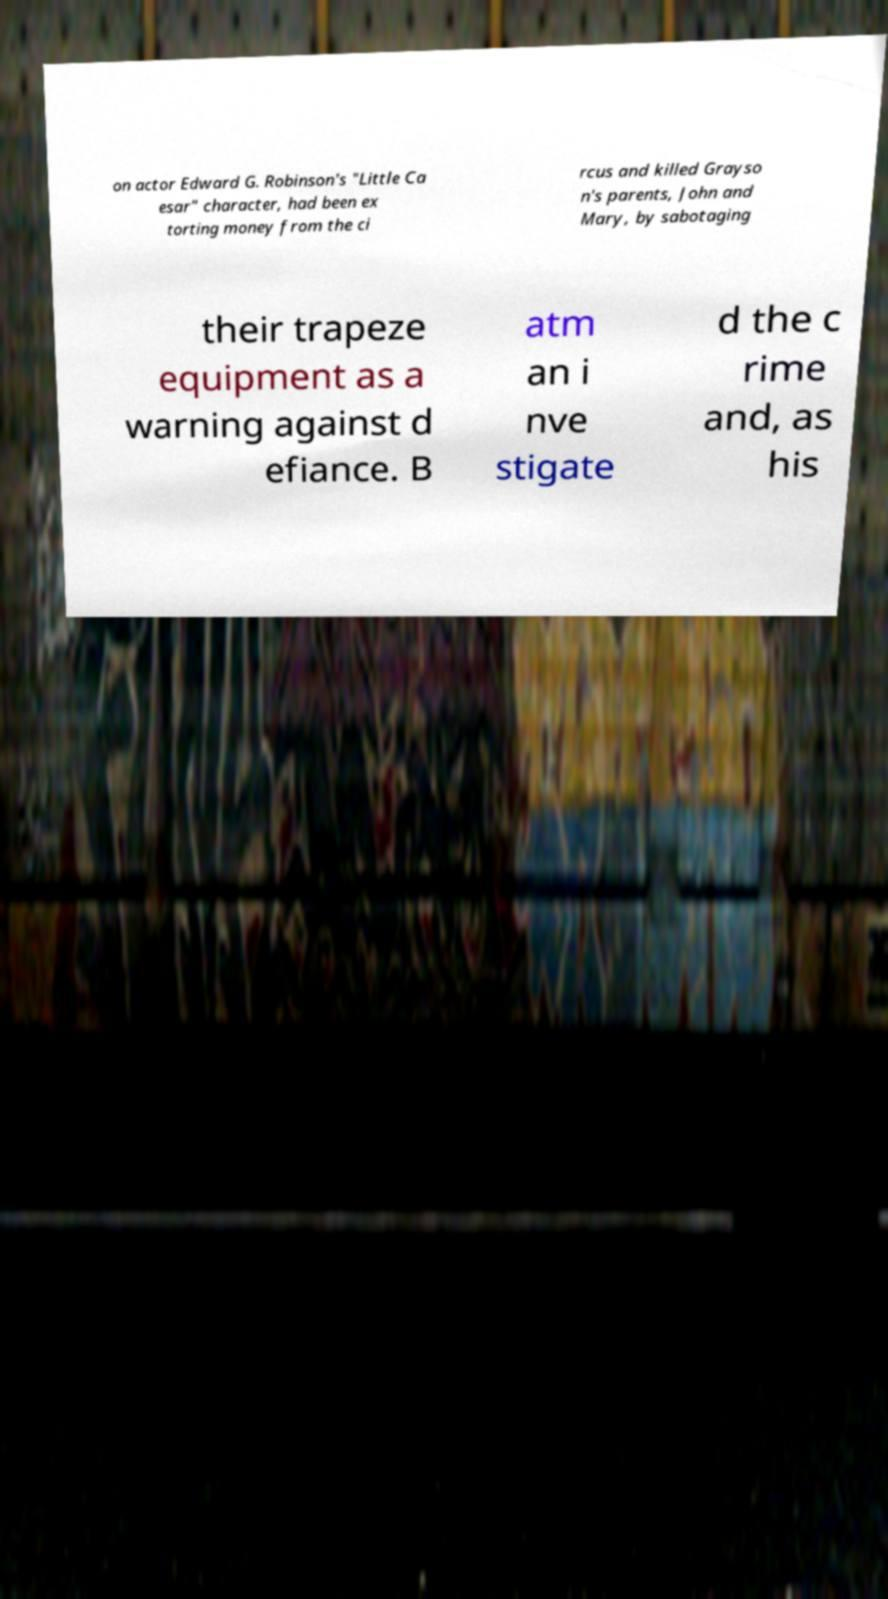Could you assist in decoding the text presented in this image and type it out clearly? on actor Edward G. Robinson's "Little Ca esar" character, had been ex torting money from the ci rcus and killed Grayso n's parents, John and Mary, by sabotaging their trapeze equipment as a warning against d efiance. B atm an i nve stigate d the c rime and, as his 